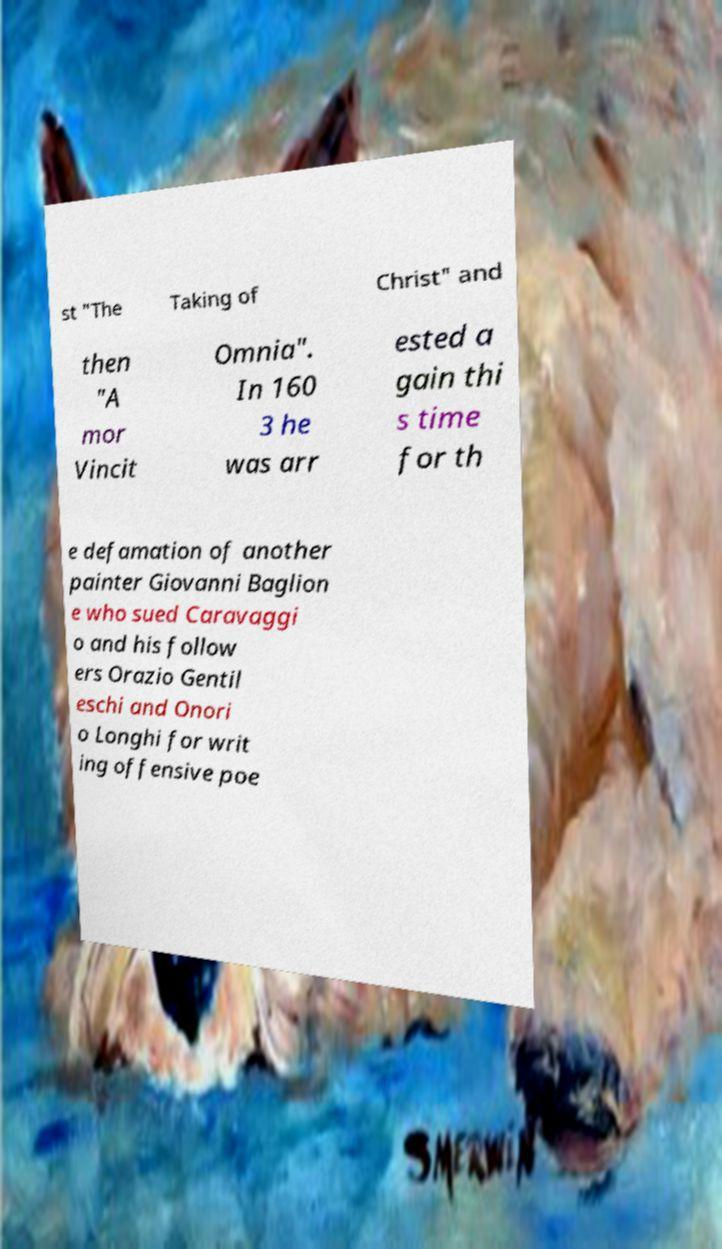What messages or text are displayed in this image? I need them in a readable, typed format. st "The Taking of Christ" and then "A mor Vincit Omnia". In 160 3 he was arr ested a gain thi s time for th e defamation of another painter Giovanni Baglion e who sued Caravaggi o and his follow ers Orazio Gentil eschi and Onori o Longhi for writ ing offensive poe 